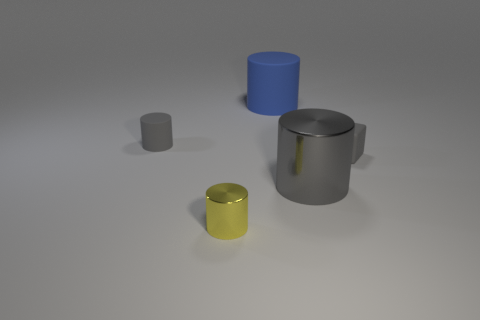Is the color of the big metal object the same as the tiny matte block?
Offer a terse response. Yes. There is a large object that is the same color as the small matte cube; what is its material?
Keep it short and to the point. Metal. Is the number of big matte cylinders that are on the right side of the small cube less than the number of tiny things that are behind the yellow cylinder?
Provide a short and direct response. Yes. Do the tiny cube and the big blue thing have the same material?
Ensure brevity in your answer.  Yes. There is a cylinder that is behind the gray metal cylinder and on the right side of the yellow metallic cylinder; what size is it?
Keep it short and to the point. Large. There is a gray matte thing that is the same size as the gray matte cylinder; what is its shape?
Offer a terse response. Cube. What is the block that is behind the gray cylinder that is right of the small gray matte object on the left side of the tiny yellow cylinder made of?
Provide a succinct answer. Rubber. There is a small gray object to the left of the tiny yellow metal cylinder; does it have the same shape as the small yellow metal thing that is in front of the big blue thing?
Give a very brief answer. Yes. How many other objects are the same material as the tiny yellow cylinder?
Provide a short and direct response. 1. Is the material of the tiny cylinder that is behind the tiny gray matte cube the same as the small object in front of the big gray object?
Offer a terse response. No. 